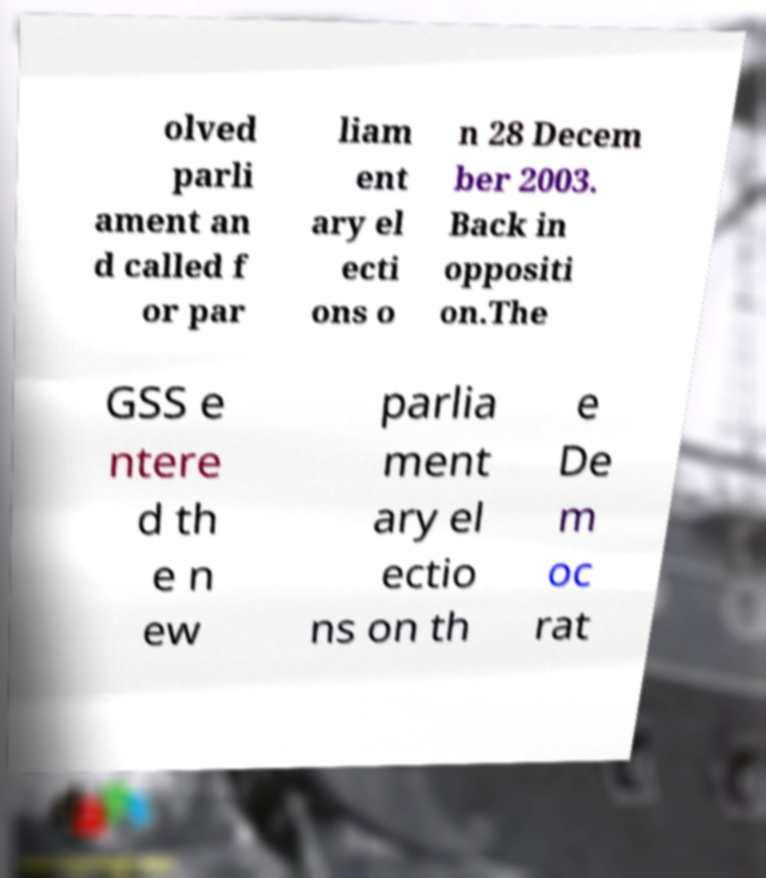Could you extract and type out the text from this image? olved parli ament an d called f or par liam ent ary el ecti ons o n 28 Decem ber 2003. Back in oppositi on.The GSS e ntere d th e n ew parlia ment ary el ectio ns on th e De m oc rat 